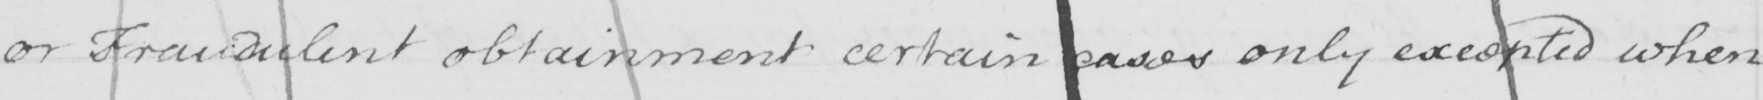What text is written in this handwritten line? or Fraudulent obtainment certain cases only excepted when 